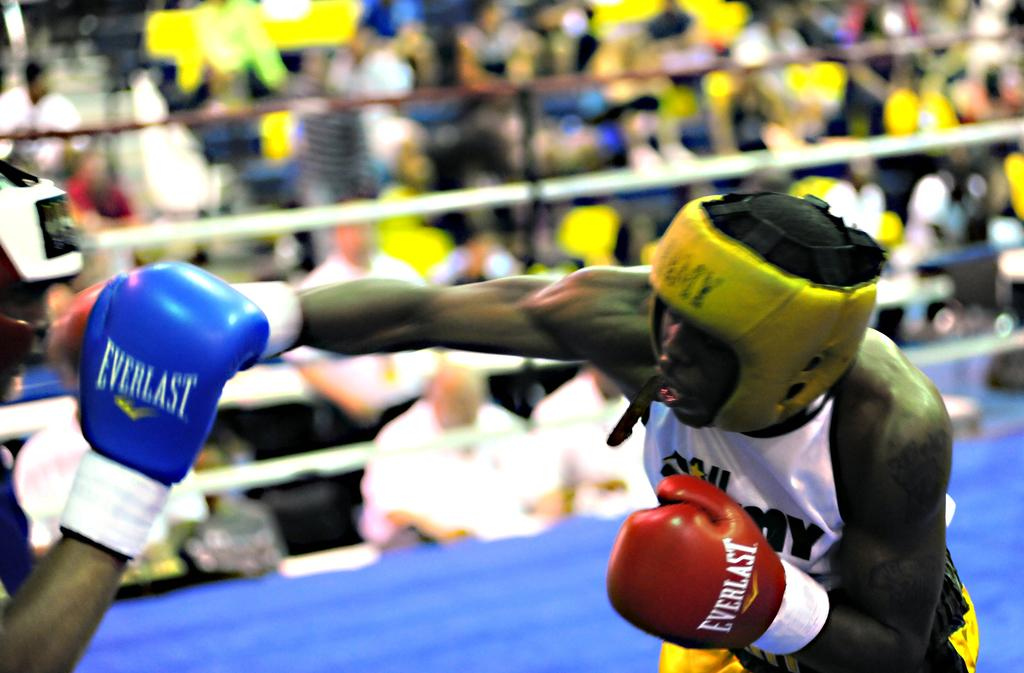How many people can be seen in the image? There are a few people in the image. What is the main feature of the image? There is a boxing ring in the image. Can you describe the background of the image? The background of the image is blurred. What grade does the person in the image have? There is no indication of a person's grade in the image. What type of knowledge is being shared in the image? There is no indication of any knowledge being shared in the image. 